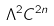Convert formula to latex. <formula><loc_0><loc_0><loc_500><loc_500>\Lambda ^ { 2 } C ^ { 2 n }</formula> 